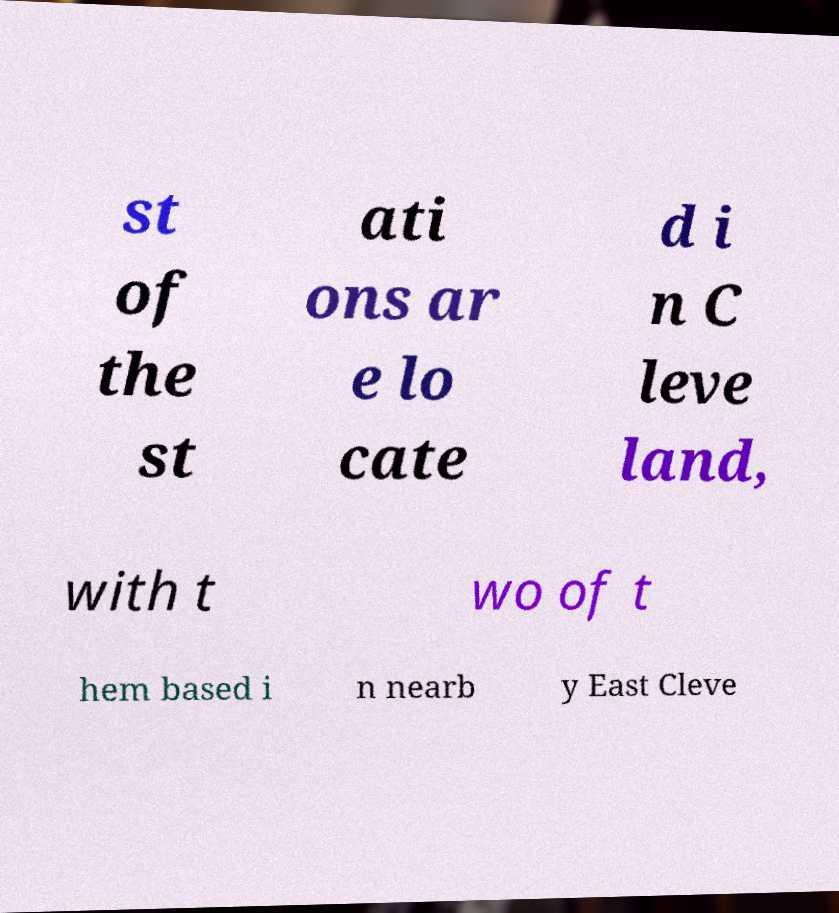There's text embedded in this image that I need extracted. Can you transcribe it verbatim? st of the st ati ons ar e lo cate d i n C leve land, with t wo of t hem based i n nearb y East Cleve 